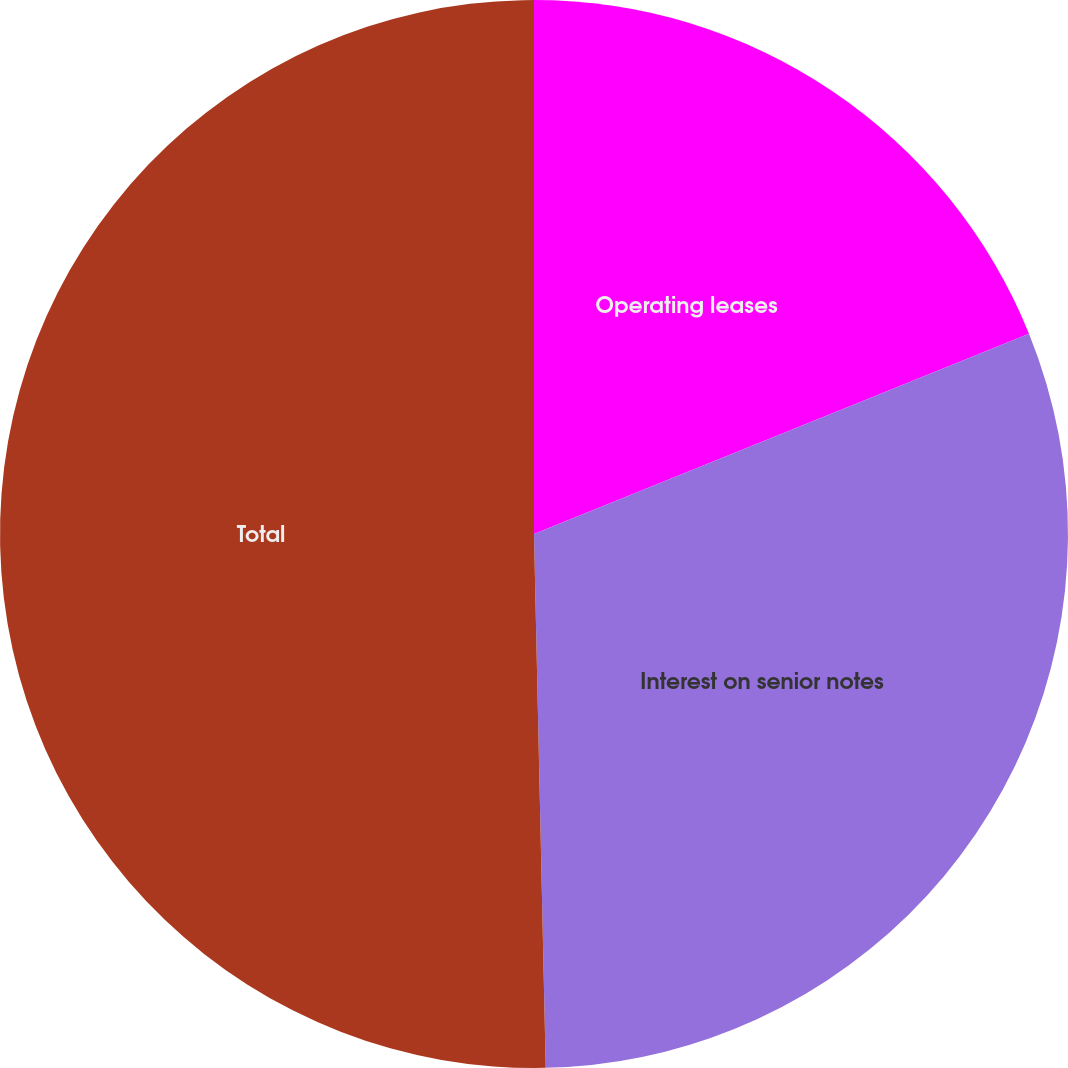<chart> <loc_0><loc_0><loc_500><loc_500><pie_chart><fcel>Operating leases<fcel>Interest on senior notes<fcel>Total<nl><fcel>18.88%<fcel>30.77%<fcel>50.35%<nl></chart> 